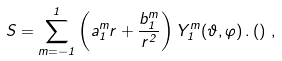<formula> <loc_0><loc_0><loc_500><loc_500>S = \sum _ { m = - 1 } ^ { 1 } \left ( a _ { 1 } ^ { m } r + \frac { b _ { 1 } ^ { m } } { r ^ { 2 } } \right ) Y _ { 1 } ^ { m } ( \vartheta , \varphi ) \, . \left ( \right ) \, ,</formula> 